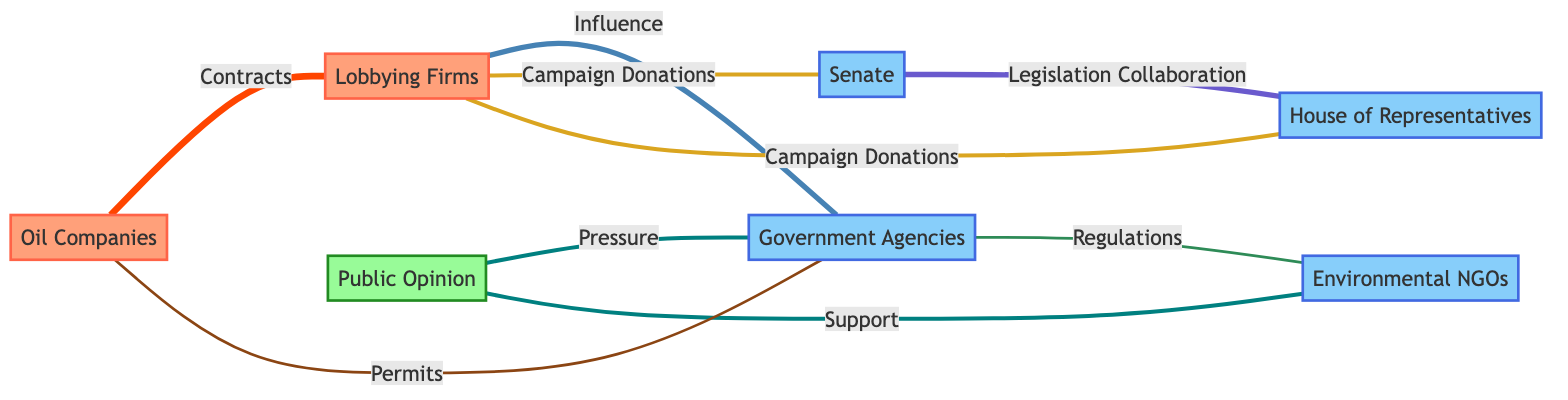What is the total number of nodes in the diagram? The diagram contains a total of 7 nodes: Oil Companies, Lobbying Firms, Government Agencies, Senate, House of Representatives, Environmental NGOs, and Public Opinion.
Answer: 7 Which node is connected to the most edges? Oil Companies is connected to Lobbying Firms and Government Agencies through contracts and permits, giving it two connections. Lobbying Firms is connected to four nodes, making it the most connected.
Answer: Lobbying Firms How many edges are there between the Senate and House of Representatives? There's one edge connecting the Senate and House of Representatives labeled "Legislation Collaboration," which indicates they have collaboration in terms of legislation.
Answer: 1 What type of influence do Lobbying Firms have on Government Agencies? The influence type is "Influence," indicating Lobbying Firms exert strategic pressure or lobbying efforts on Government Agencies.
Answer: Influence What is the weight of the edge connecting Environmental NGOs to Government Agencies? The edge connecting Environmental NGOs to Government Agencies has a weight of 2, representing the strength of the relationship in terms of regulations.
Answer: 2 Which node receives support from Public Opinion? Environmental NGOs receive support from Public Opinion, indicating that the public backs these organizations in their actions or initiatives.
Answer: Environmental NGOs What is the relationship described between Public Opinion and Government Agencies? The relationship is described as "Pressure," showing that Public Opinion exerts pressure on Government Agencies to possibly influence their policies or decisions.
Answer: Pressure Which two nodes are involved in campaign donations? Lobbying Firms are connected to both the Senate and the House of Representatives through edges labeled "Campaign Donations," indicating their role in financing political entities.
Answer: Senate and House of Representatives Which group belongs to the "Industry" category? The nodes "Oil Companies" and "Lobbying Firms" belong to the "Industry" category, indicating their business nature in the oil sector.
Answer: Oil Companies and Lobbying Firms 